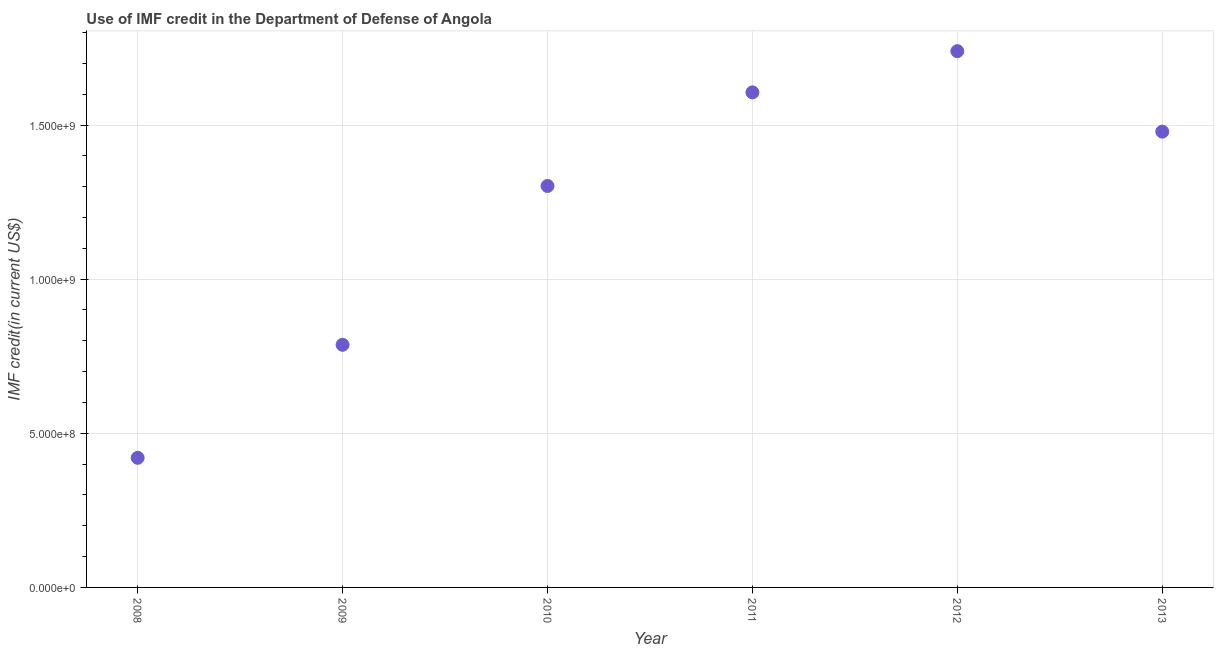What is the use of imf credit in dod in 2012?
Make the answer very short. 1.74e+09. Across all years, what is the maximum use of imf credit in dod?
Ensure brevity in your answer.  1.74e+09. Across all years, what is the minimum use of imf credit in dod?
Your answer should be very brief. 4.21e+08. In which year was the use of imf credit in dod maximum?
Offer a very short reply. 2012. In which year was the use of imf credit in dod minimum?
Keep it short and to the point. 2008. What is the sum of the use of imf credit in dod?
Offer a very short reply. 7.33e+09. What is the difference between the use of imf credit in dod in 2008 and 2013?
Your response must be concise. -1.06e+09. What is the average use of imf credit in dod per year?
Provide a succinct answer. 1.22e+09. What is the median use of imf credit in dod?
Give a very brief answer. 1.39e+09. What is the ratio of the use of imf credit in dod in 2012 to that in 2013?
Offer a very short reply. 1.18. Is the use of imf credit in dod in 2008 less than that in 2012?
Provide a short and direct response. Yes. What is the difference between the highest and the second highest use of imf credit in dod?
Give a very brief answer. 1.34e+08. What is the difference between the highest and the lowest use of imf credit in dod?
Your answer should be very brief. 1.32e+09. In how many years, is the use of imf credit in dod greater than the average use of imf credit in dod taken over all years?
Offer a very short reply. 4. Does the use of imf credit in dod monotonically increase over the years?
Keep it short and to the point. No. How many dotlines are there?
Keep it short and to the point. 1. How many years are there in the graph?
Provide a short and direct response. 6. What is the difference between two consecutive major ticks on the Y-axis?
Provide a short and direct response. 5.00e+08. Are the values on the major ticks of Y-axis written in scientific E-notation?
Your answer should be compact. Yes. Does the graph contain any zero values?
Your answer should be compact. No. What is the title of the graph?
Keep it short and to the point. Use of IMF credit in the Department of Defense of Angola. What is the label or title of the Y-axis?
Ensure brevity in your answer.  IMF credit(in current US$). What is the IMF credit(in current US$) in 2008?
Your answer should be compact. 4.21e+08. What is the IMF credit(in current US$) in 2009?
Offer a terse response. 7.87e+08. What is the IMF credit(in current US$) in 2010?
Your answer should be compact. 1.30e+09. What is the IMF credit(in current US$) in 2011?
Keep it short and to the point. 1.61e+09. What is the IMF credit(in current US$) in 2012?
Provide a short and direct response. 1.74e+09. What is the IMF credit(in current US$) in 2013?
Keep it short and to the point. 1.48e+09. What is the difference between the IMF credit(in current US$) in 2008 and 2009?
Your answer should be very brief. -3.67e+08. What is the difference between the IMF credit(in current US$) in 2008 and 2010?
Your answer should be very brief. -8.82e+08. What is the difference between the IMF credit(in current US$) in 2008 and 2011?
Offer a terse response. -1.19e+09. What is the difference between the IMF credit(in current US$) in 2008 and 2012?
Keep it short and to the point. -1.32e+09. What is the difference between the IMF credit(in current US$) in 2008 and 2013?
Provide a succinct answer. -1.06e+09. What is the difference between the IMF credit(in current US$) in 2009 and 2010?
Offer a very short reply. -5.15e+08. What is the difference between the IMF credit(in current US$) in 2009 and 2011?
Provide a succinct answer. -8.19e+08. What is the difference between the IMF credit(in current US$) in 2009 and 2012?
Keep it short and to the point. -9.53e+08. What is the difference between the IMF credit(in current US$) in 2009 and 2013?
Provide a succinct answer. -6.92e+08. What is the difference between the IMF credit(in current US$) in 2010 and 2011?
Your response must be concise. -3.04e+08. What is the difference between the IMF credit(in current US$) in 2010 and 2012?
Provide a short and direct response. -4.37e+08. What is the difference between the IMF credit(in current US$) in 2010 and 2013?
Provide a succinct answer. -1.76e+08. What is the difference between the IMF credit(in current US$) in 2011 and 2012?
Offer a terse response. -1.34e+08. What is the difference between the IMF credit(in current US$) in 2011 and 2013?
Your answer should be very brief. 1.27e+08. What is the difference between the IMF credit(in current US$) in 2012 and 2013?
Offer a terse response. 2.61e+08. What is the ratio of the IMF credit(in current US$) in 2008 to that in 2009?
Keep it short and to the point. 0.53. What is the ratio of the IMF credit(in current US$) in 2008 to that in 2010?
Keep it short and to the point. 0.32. What is the ratio of the IMF credit(in current US$) in 2008 to that in 2011?
Provide a short and direct response. 0.26. What is the ratio of the IMF credit(in current US$) in 2008 to that in 2012?
Offer a very short reply. 0.24. What is the ratio of the IMF credit(in current US$) in 2008 to that in 2013?
Your response must be concise. 0.28. What is the ratio of the IMF credit(in current US$) in 2009 to that in 2010?
Offer a terse response. 0.6. What is the ratio of the IMF credit(in current US$) in 2009 to that in 2011?
Make the answer very short. 0.49. What is the ratio of the IMF credit(in current US$) in 2009 to that in 2012?
Give a very brief answer. 0.45. What is the ratio of the IMF credit(in current US$) in 2009 to that in 2013?
Provide a succinct answer. 0.53. What is the ratio of the IMF credit(in current US$) in 2010 to that in 2011?
Provide a succinct answer. 0.81. What is the ratio of the IMF credit(in current US$) in 2010 to that in 2012?
Offer a terse response. 0.75. What is the ratio of the IMF credit(in current US$) in 2010 to that in 2013?
Your answer should be very brief. 0.88. What is the ratio of the IMF credit(in current US$) in 2011 to that in 2012?
Provide a succinct answer. 0.92. What is the ratio of the IMF credit(in current US$) in 2011 to that in 2013?
Your answer should be compact. 1.09. What is the ratio of the IMF credit(in current US$) in 2012 to that in 2013?
Make the answer very short. 1.18. 